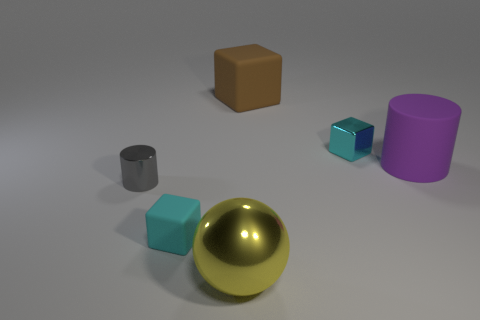Are there any other things that have the same shape as the brown object?
Offer a terse response. Yes. What number of spheres are either tiny cyan matte things or large brown objects?
Ensure brevity in your answer.  0. There is a shiny thing to the right of the shiny ball; is its color the same as the small matte block?
Provide a short and direct response. Yes. What material is the small cyan thing right of the rubber cube in front of the cyan thing that is behind the rubber cylinder?
Your answer should be compact. Metal. Do the cyan metal block and the cyan rubber thing have the same size?
Give a very brief answer. Yes. There is a small rubber thing; is it the same color as the tiny object to the right of the large block?
Your answer should be very brief. Yes. There is a tiny cyan thing that is the same material as the tiny gray cylinder; what is its shape?
Your answer should be very brief. Cube. There is a big matte object to the left of the purple matte thing; is it the same shape as the tiny gray thing?
Make the answer very short. No. How big is the rubber block that is in front of the tiny cube right of the big brown object?
Offer a terse response. Small. The big object that is made of the same material as the large cube is what color?
Give a very brief answer. Purple. 